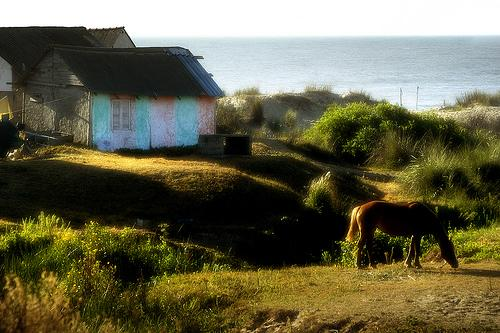Write a short, 8-word description of the image. Brown horse grazes near house, water, and hills. Provide an imaginative interpretation of the image, adding fantasy elements. As a magical brown horse feasts on enchanted grass, the guardian cottage watches over the mystical fields, flowing hills, and a shimmering ocean portal. Describe the picture, emphasizing the elements related to nature. A harmonious natural scene unfolds as a brown horse eats grass, wildflowers bloom, and a body of water gently laps the shore, all framed by a charming house. Provide a simple description of the scene in the image. A brown horse eating grass near a house and wooden stall, with wildflowers, hills, and a body of water in the background. Describe the image as if explaining it to a child. There's a cute brown horse eating some grass near a little house. There are pretty flowers, a wooden shed, and some water nearby. Imagine you are a real estate agent, describe the scene in the image to entice potential buyers. Nestled amidst rolling hills, experience nature's harmony with a charming house, as you watch horses graze among wildflowers and enjoy the tranquil seaside views. Mention the key elements present in the picture and their relationship to each other. A brown horse peacefully eating grass in a field adjacent to a cozy house with a wooden stall, surrounded by nature's beauty in the form of hills and water. Illustrate the setting of the image in a poetic manner. A brown horse grazing amidst wildflowers, as the gentle waves of a nearby ocean kiss the sandy shore, with a quaint cottage standing witness. Provide a brief, factual description of the image's content. Image shows a brown horse eating grass, a small house, wooden stall, wildflowers, hills, and a body of water. Use a metaphor to describe the scene in the image. A brown horse, as the serene field's adorning jewel, grazes among vibrant flowers amidst the protective hug of hills and an ocean's lullaby. 